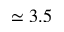Convert formula to latex. <formula><loc_0><loc_0><loc_500><loc_500>\simeq 3 . 5</formula> 